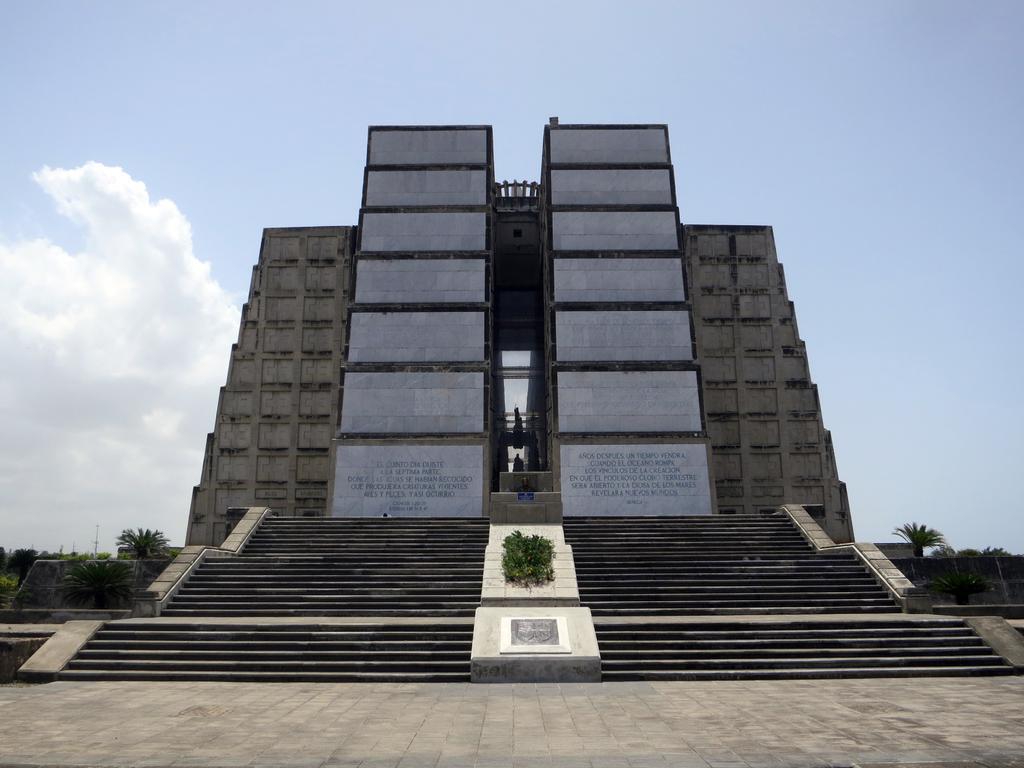Can you describe this image briefly? In the picture we can see a surface with tiles on it, we can see the steps and top of it, we can see a wall construction with two sides and on it we can see some information is mentioned and beside it we can see some plants and behind it we can see the sky with clouds. 